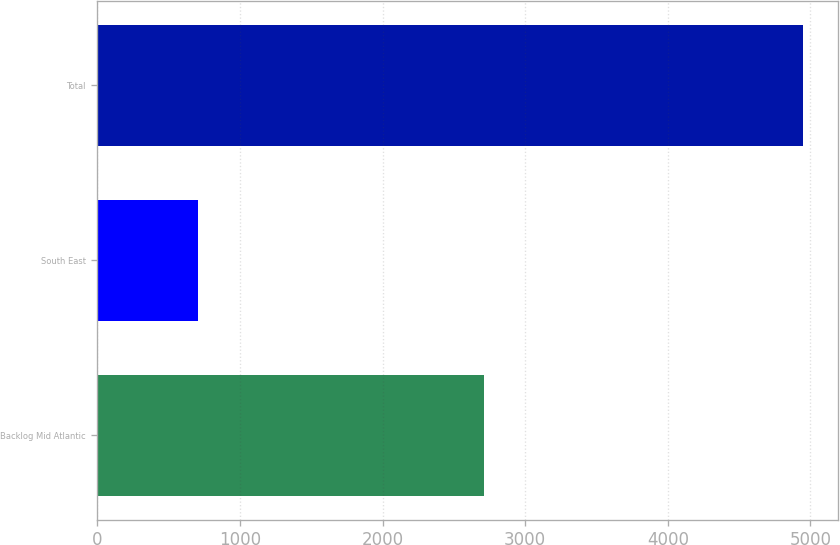<chart> <loc_0><loc_0><loc_500><loc_500><bar_chart><fcel>Backlog Mid Atlantic<fcel>South East<fcel>Total<nl><fcel>2710<fcel>708<fcel>4945<nl></chart> 